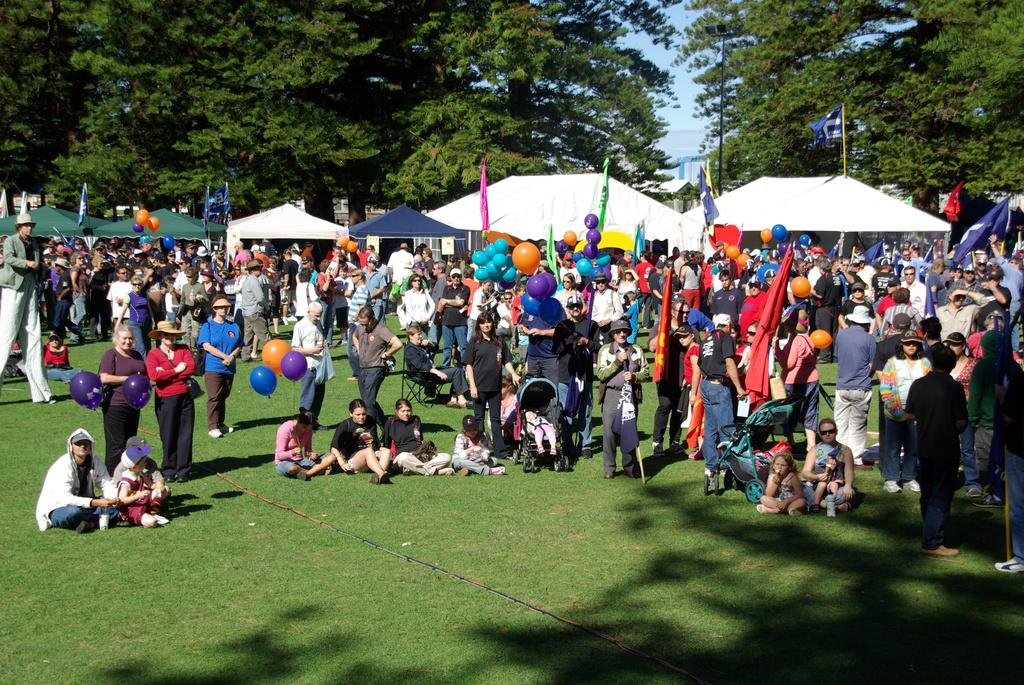What is happening in the image involving the people on the ground? There are many people on the ground in the image, but their specific activity is not clear. What type of temporary shelter can be seen in the background? There are tents for shelter in the background. What can be seen flying in the image? There are flags in the image. What type of decoration is present in the image? There are balloons in the image. What type of vegetation is visible in the background? There are trees in the background. What is visible above the people and tents in the image? The sky is visible in the image. How many carriages are present in the image? There are no carriages present in the image. What type of bikes are being ridden by the people in the image? There are no bikes present in the image. 